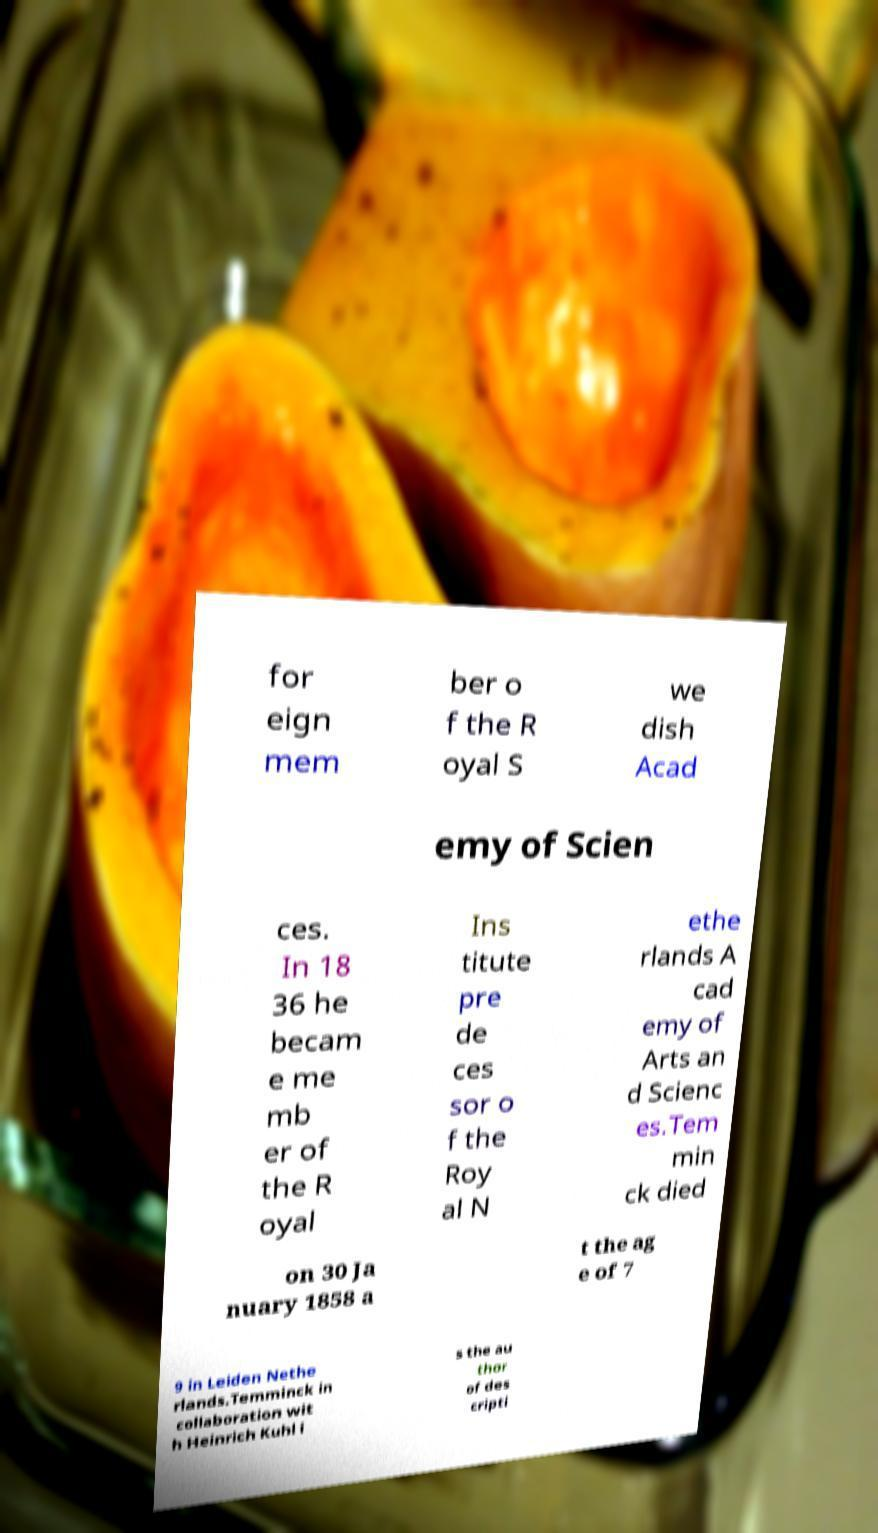Please identify and transcribe the text found in this image. for eign mem ber o f the R oyal S we dish Acad emy of Scien ces. In 18 36 he becam e me mb er of the R oyal Ins titute pre de ces sor o f the Roy al N ethe rlands A cad emy of Arts an d Scienc es.Tem min ck died on 30 Ja nuary 1858 a t the ag e of 7 9 in Leiden Nethe rlands.Temminck in collaboration wit h Heinrich Kuhl i s the au thor of des cripti 